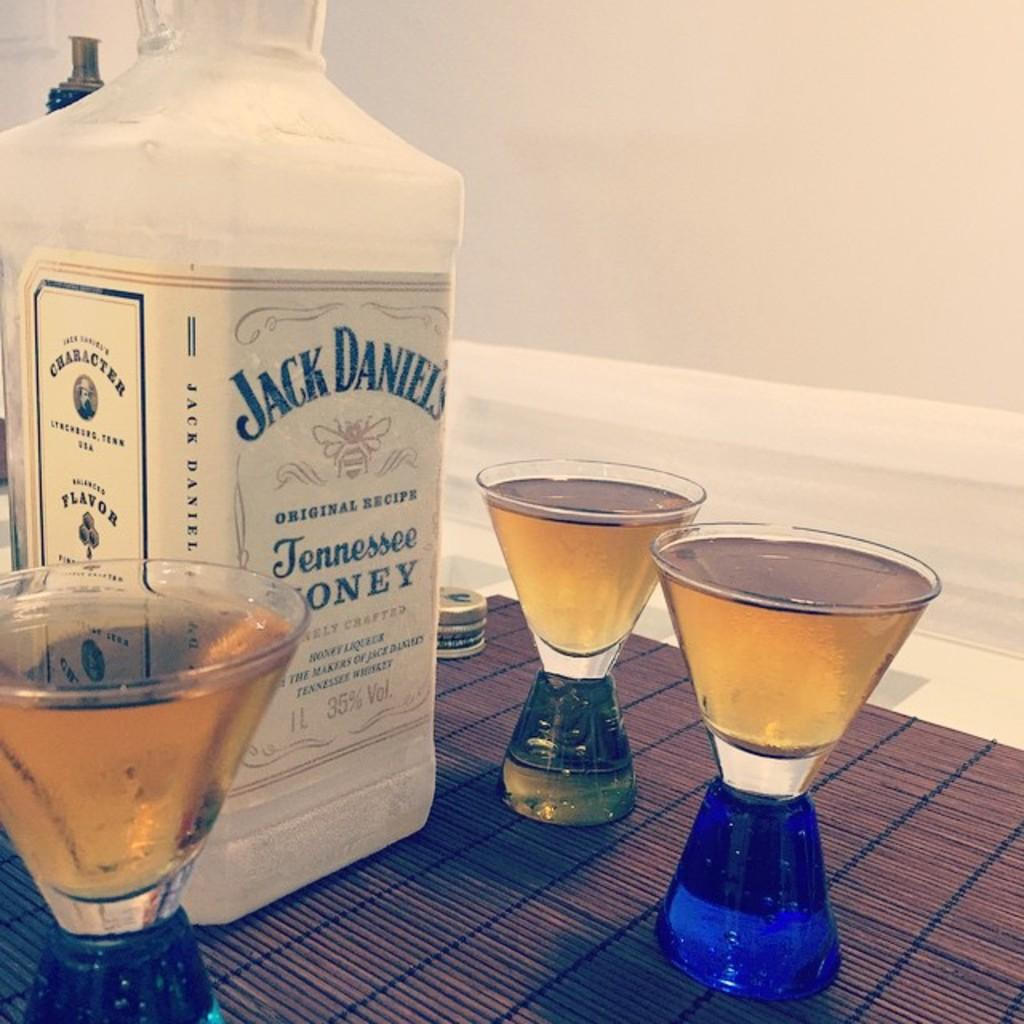<image>
Offer a succinct explanation of the picture presented. A bottle of Jack Daniels Tennessee Honey sits on a table surrounded by shot glasses. 